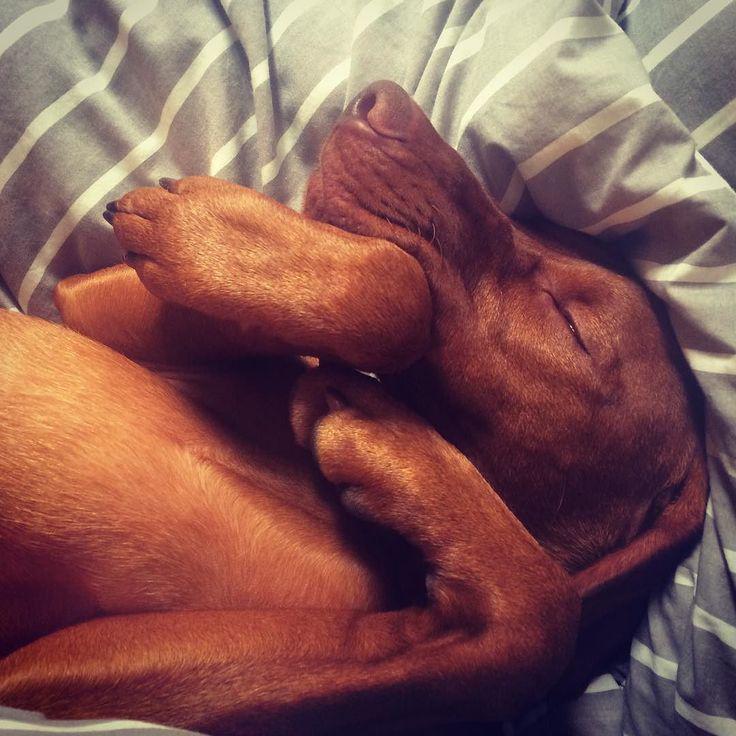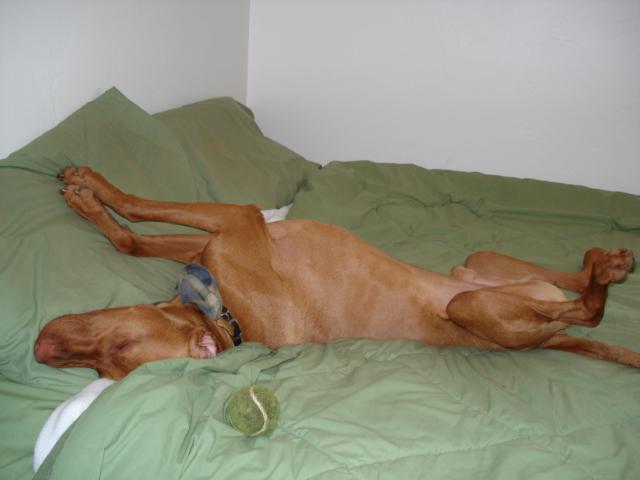The first image is the image on the left, the second image is the image on the right. For the images displayed, is the sentence "The left image shows one dog gazing with an upright head, and the right image shows a dog reclining with its front paws forward and its head rightside-up." factually correct? Answer yes or no. No. The first image is the image on the left, the second image is the image on the right. Examine the images to the left and right. Is the description "A dog is laying on its stomach in the right image." accurate? Answer yes or no. No. 